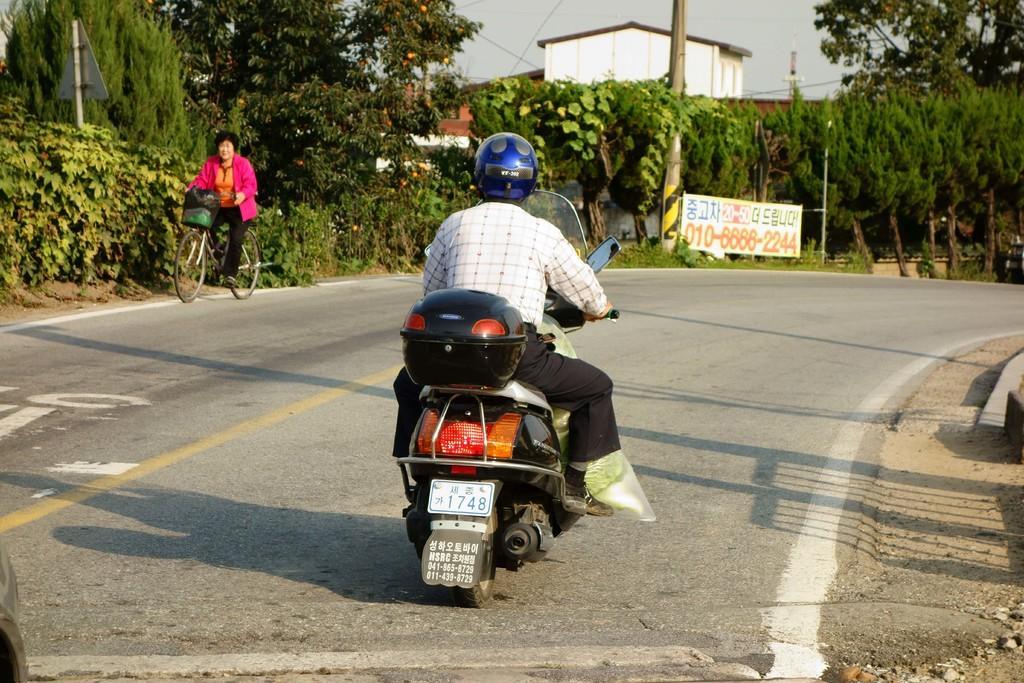Can you describe this image briefly? In the center of the image we can see a person wearing a helmet is riding a motorcycle placed on the ground. To the left side of the image we can see a woman wearing pink dress is riding a bicycle. In the background, we can see a banner with text, pole, building and a group of trees. 